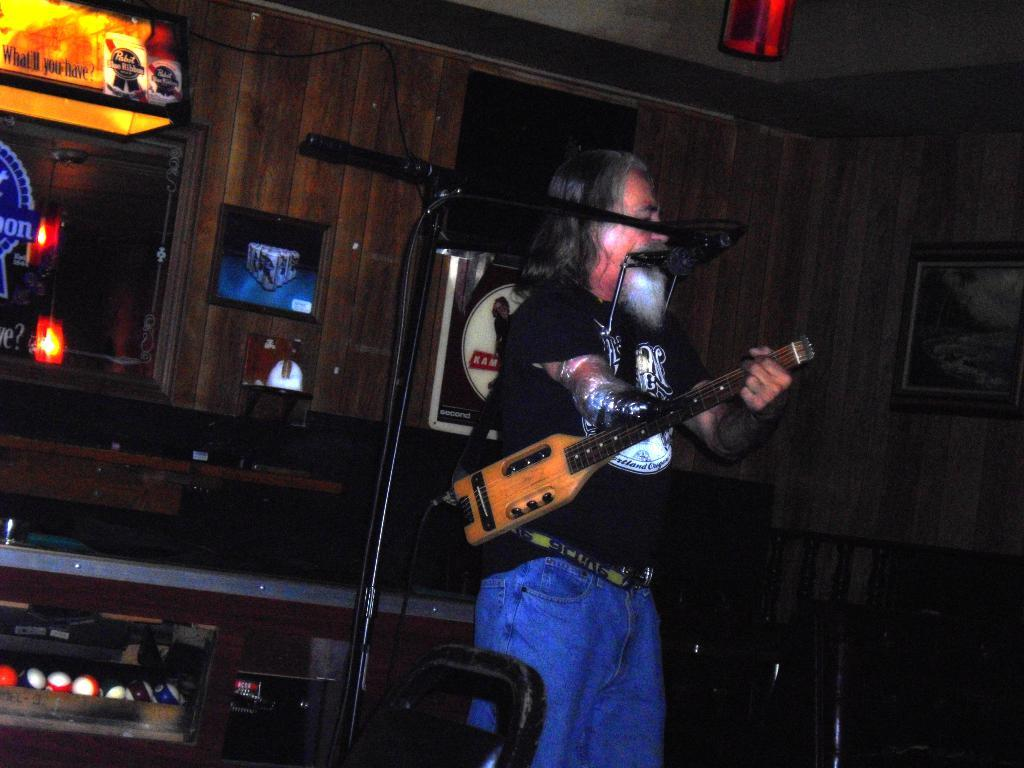Provide a one-sentence caption for the provided image. A man plays a stringed instrument next to a pool table illuminated with a Pabst Blue Ribbon light. 